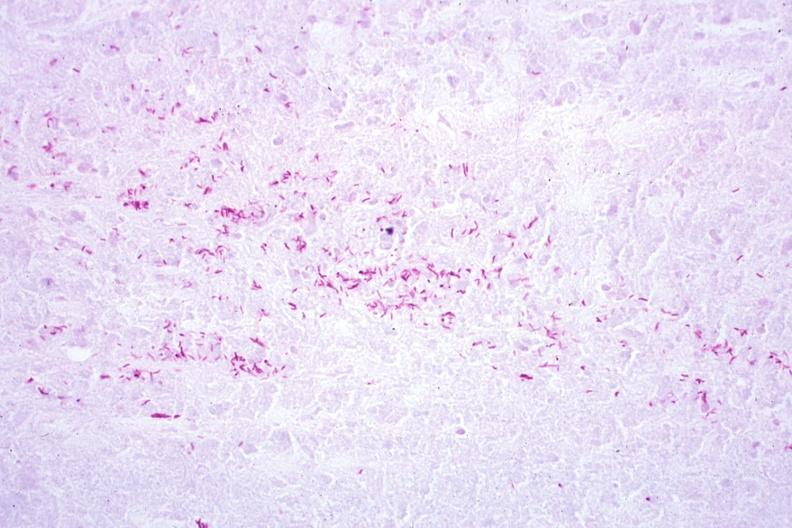s adenoma sebaceum present?
Answer the question using a single word or phrase. No 